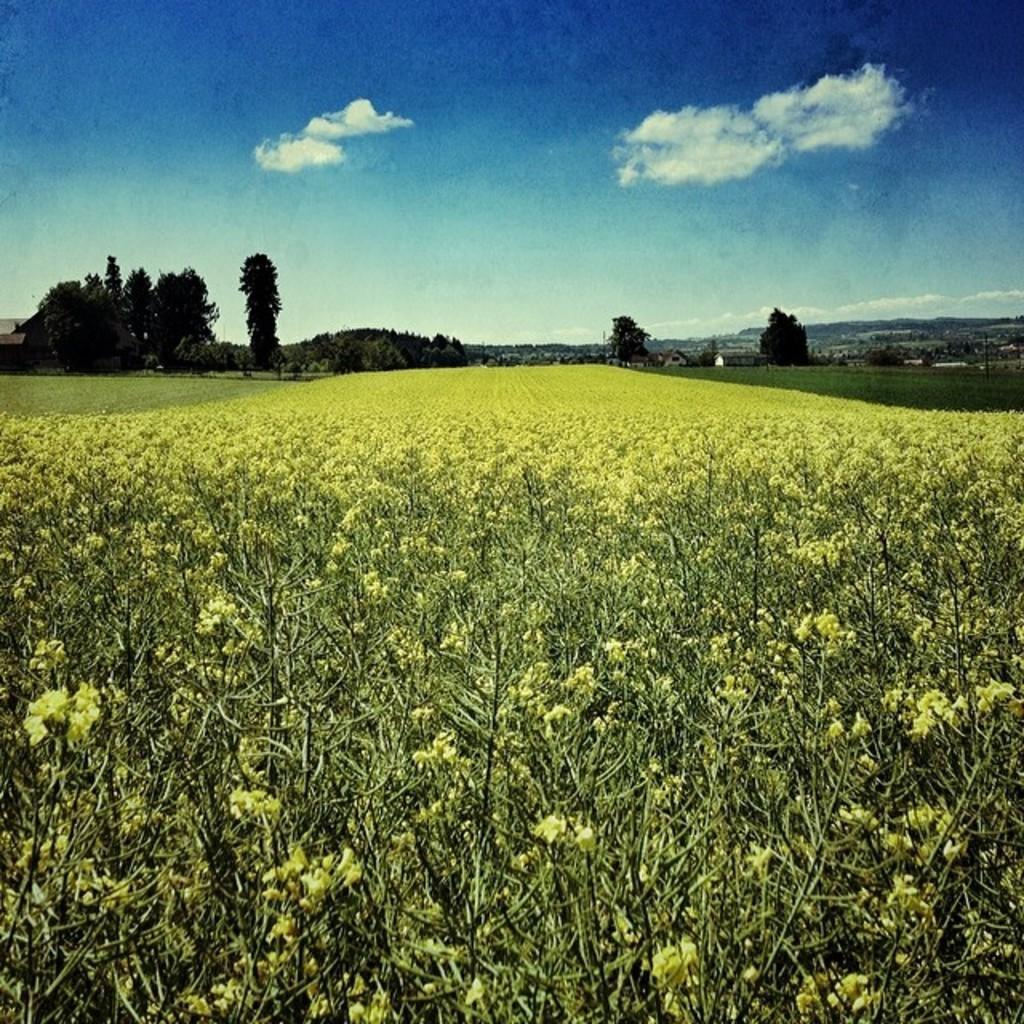In one or two sentences, can you explain what this image depicts? This picture is taken from the outside of the city. In this image, in the middle, we can see some plants with flowers which are in yellow in color. On the right side, we can see some trees, plants. On the left side, we can also see some trees and plants. In the background, we can see some mountains. At the top, we can see a sky which is a bit cloudy, at the bottom, we can see a grass. 